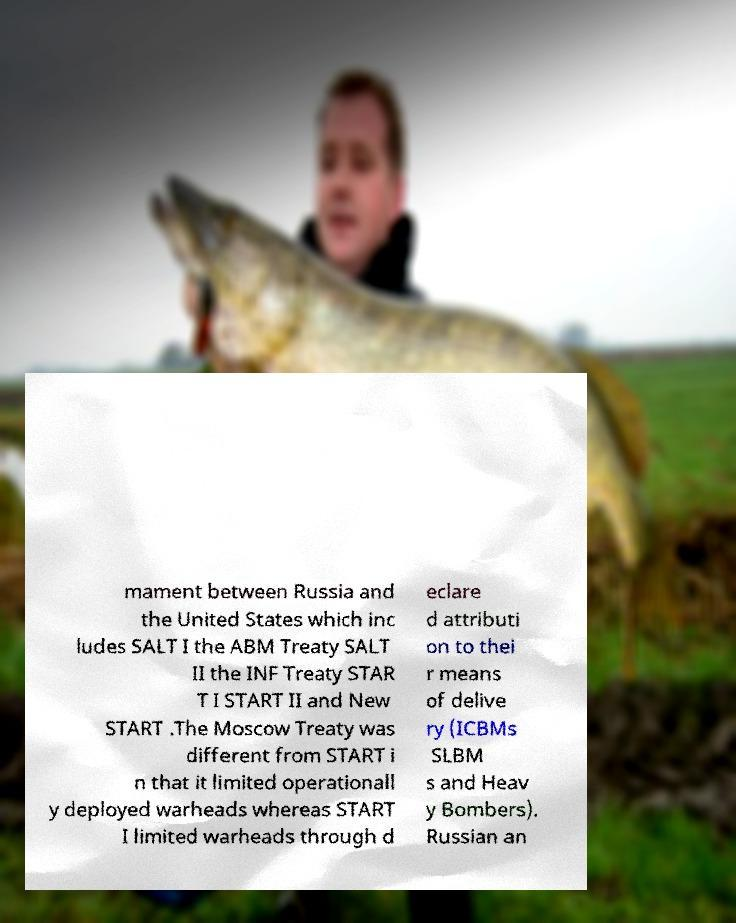Please read and relay the text visible in this image. What does it say? mament between Russia and the United States which inc ludes SALT I the ABM Treaty SALT II the INF Treaty STAR T I START II and New START .The Moscow Treaty was different from START i n that it limited operationall y deployed warheads whereas START I limited warheads through d eclare d attributi on to thei r means of delive ry (ICBMs SLBM s and Heav y Bombers). Russian an 